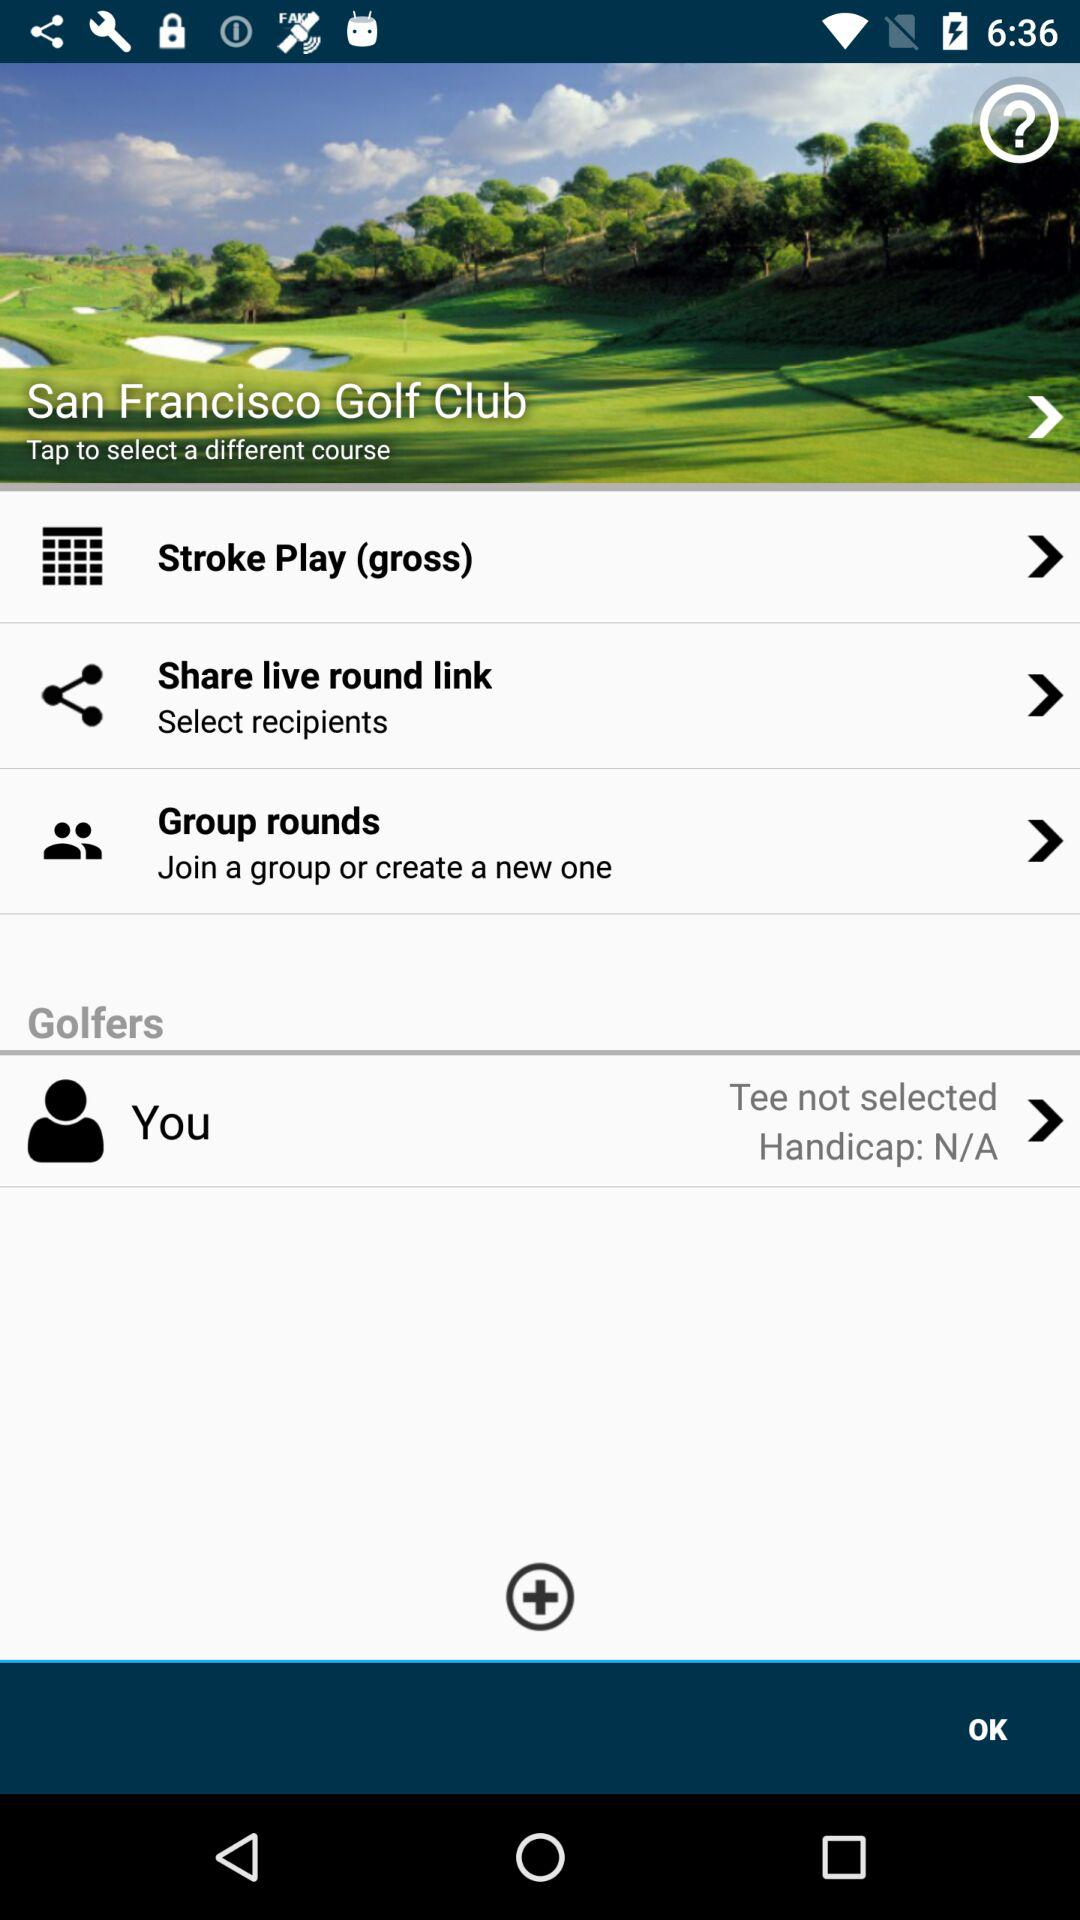What is the location of the golf club? The location of the golf club is San Francisco. 